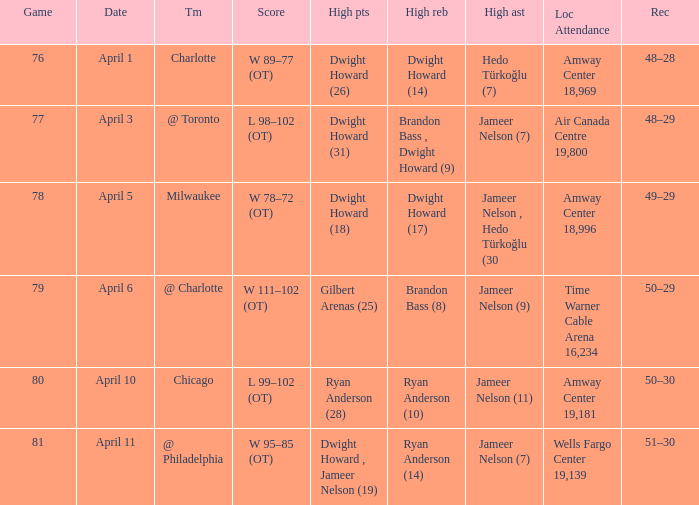Where did the match take place and what was the number of attendees on april 3? Air Canada Centre 19,800. 